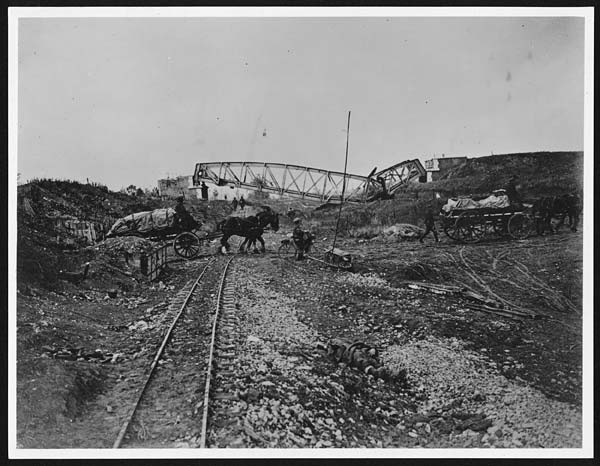What kind of photo is it in terms of color? The photo appears to be a black-and-white image, giving it a vintage and historical feel. 